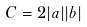Convert formula to latex. <formula><loc_0><loc_0><loc_500><loc_500>C = 2 | a | | b |</formula> 